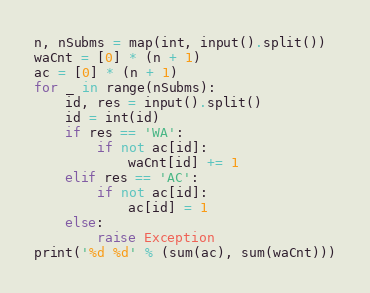Convert code to text. <code><loc_0><loc_0><loc_500><loc_500><_Python_>n, nSubms = map(int, input().split())
waCnt = [0] * (n + 1)
ac = [0] * (n + 1)
for _ in range(nSubms):
    id, res = input().split()
    id = int(id)
    if res == 'WA':
        if not ac[id]:
            waCnt[id] += 1
    elif res == 'AC':
        if not ac[id]:
            ac[id] = 1
    else:
        raise Exception
print('%d %d' % (sum(ac), sum(waCnt)))
</code> 